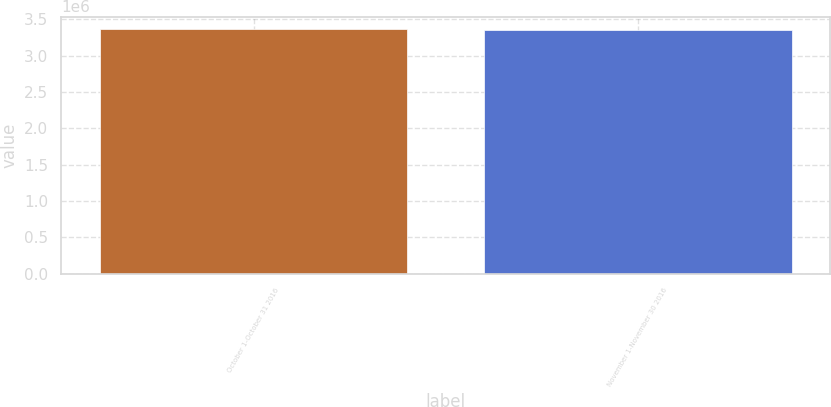Convert chart to OTSL. <chart><loc_0><loc_0><loc_500><loc_500><bar_chart><fcel>October 1-October 31 2016<fcel>November 1-November 30 2016<nl><fcel>3.36702e+06<fcel>3.35163e+06<nl></chart> 